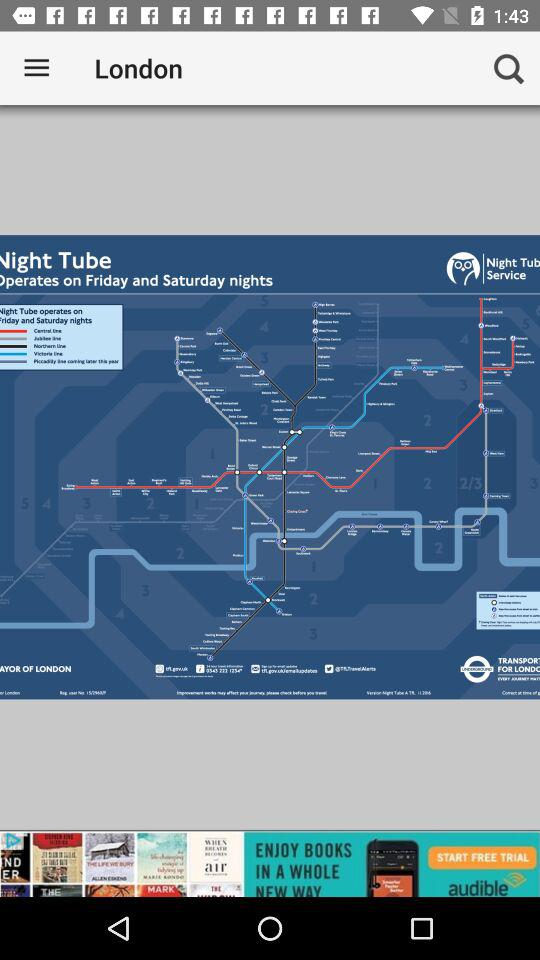What's the location? The location is London. 